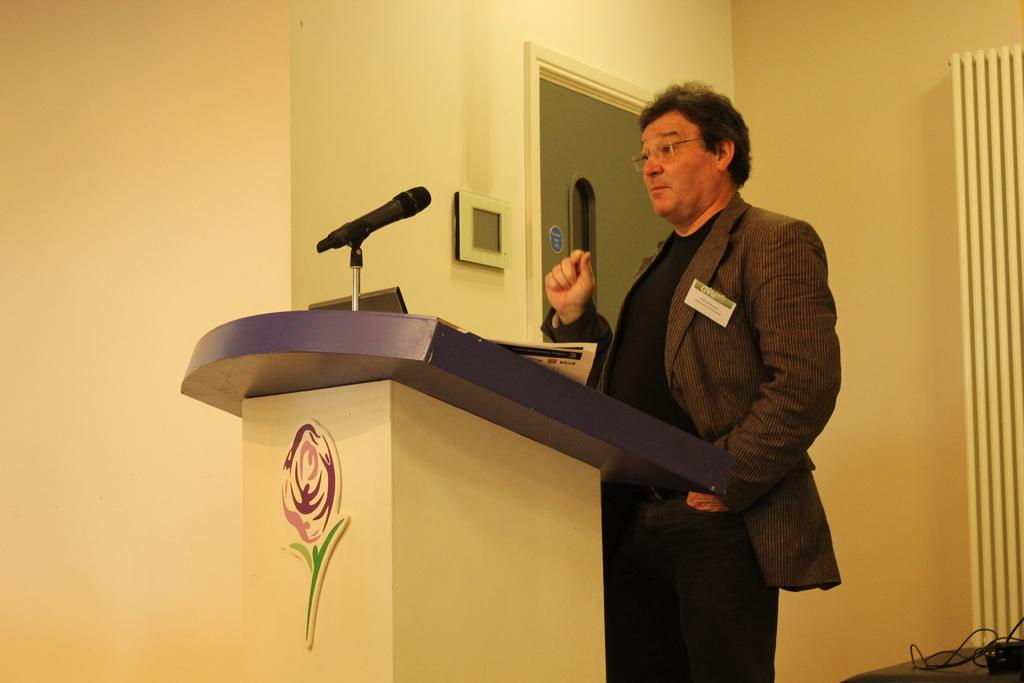What is the man in the image doing? The man is standing near a podium in the image. What is the man wearing? The man is wearing a coat in the image. What object is present near the man? There is a microphone in the image. What is the color of the microphone? The microphone is black in color. What invention is the man presenting to the committee in the image? There is no committee or invention present in the image; it only shows a man standing near a podium with a microphone. 